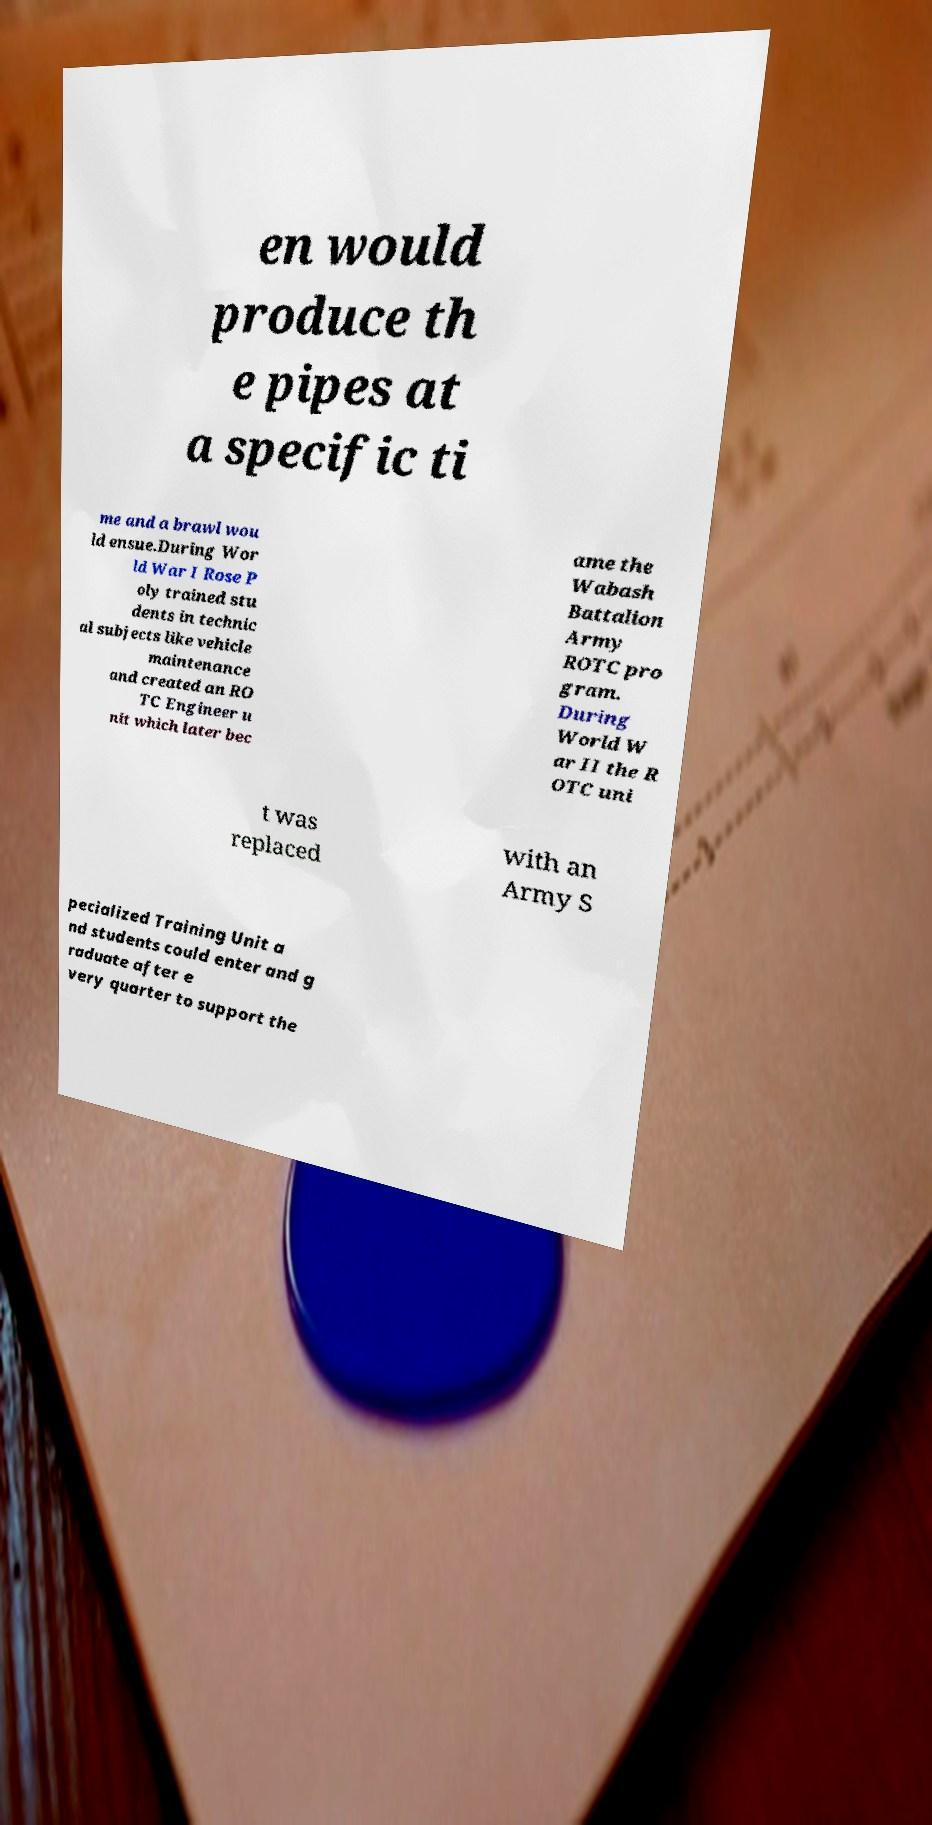Can you read and provide the text displayed in the image?This photo seems to have some interesting text. Can you extract and type it out for me? en would produce th e pipes at a specific ti me and a brawl wou ld ensue.During Wor ld War I Rose P oly trained stu dents in technic al subjects like vehicle maintenance and created an RO TC Engineer u nit which later bec ame the Wabash Battalion Army ROTC pro gram. During World W ar II the R OTC uni t was replaced with an Army S pecialized Training Unit a nd students could enter and g raduate after e very quarter to support the 